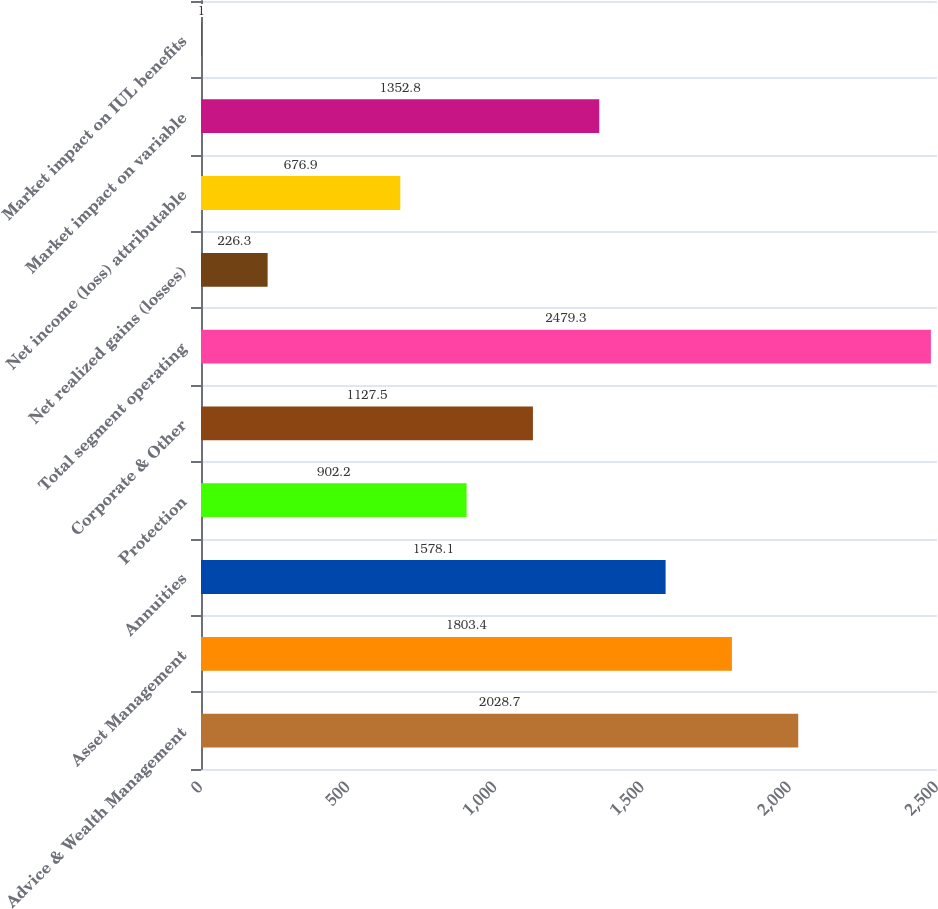<chart> <loc_0><loc_0><loc_500><loc_500><bar_chart><fcel>Advice & Wealth Management<fcel>Asset Management<fcel>Annuities<fcel>Protection<fcel>Corporate & Other<fcel>Total segment operating<fcel>Net realized gains (losses)<fcel>Net income (loss) attributable<fcel>Market impact on variable<fcel>Market impact on IUL benefits<nl><fcel>2028.7<fcel>1803.4<fcel>1578.1<fcel>902.2<fcel>1127.5<fcel>2479.3<fcel>226.3<fcel>676.9<fcel>1352.8<fcel>1<nl></chart> 